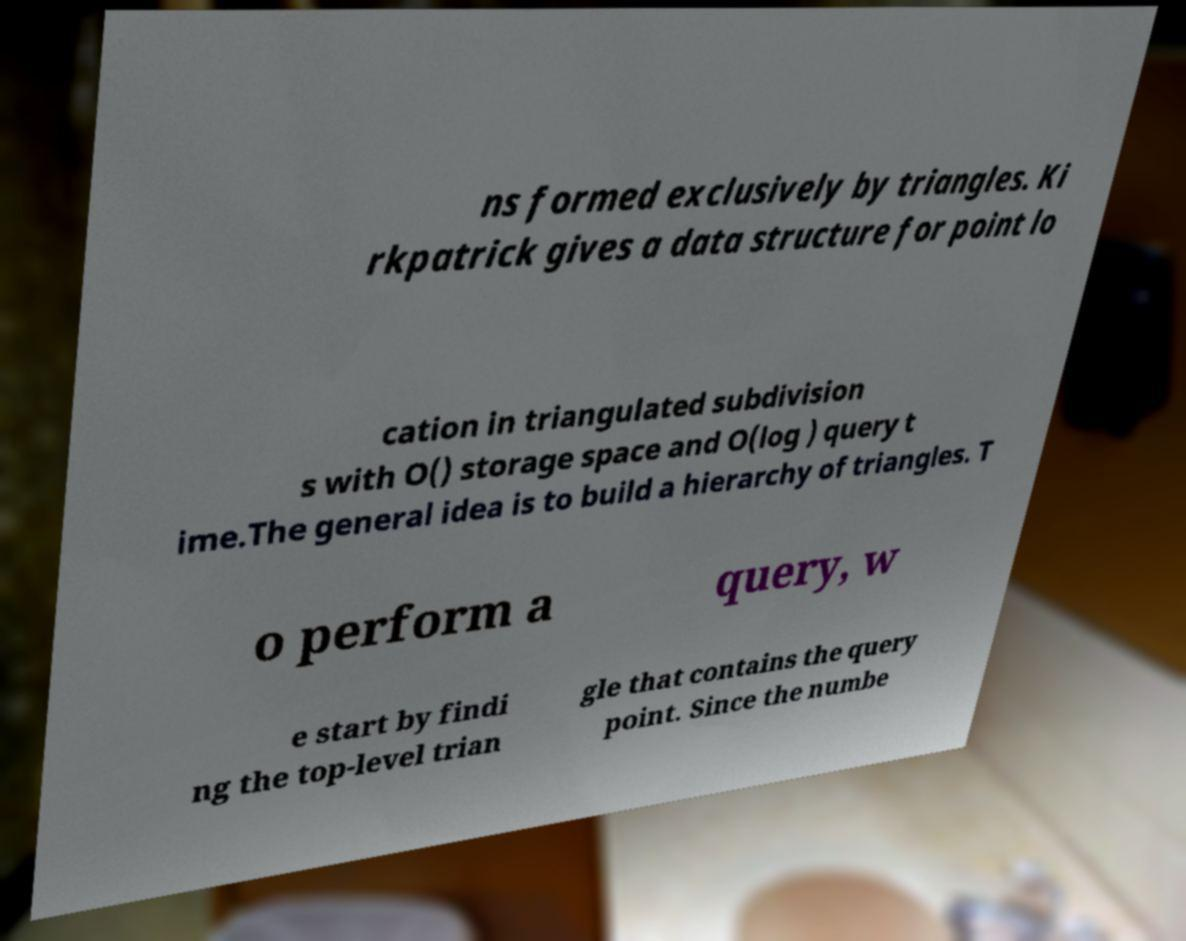Please identify and transcribe the text found in this image. ns formed exclusively by triangles. Ki rkpatrick gives a data structure for point lo cation in triangulated subdivision s with O() storage space and O(log ) query t ime.The general idea is to build a hierarchy of triangles. T o perform a query, w e start by findi ng the top-level trian gle that contains the query point. Since the numbe 